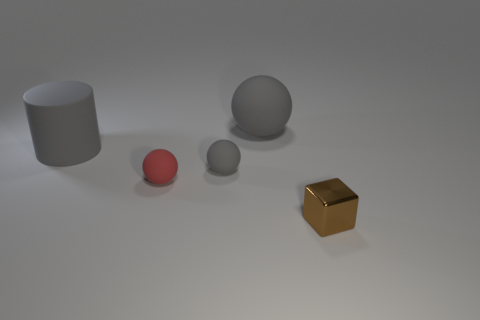Subtract all tiny rubber spheres. How many spheres are left? 1 Subtract all gray spheres. How many spheres are left? 1 Subtract all green cylinders. How many red spheres are left? 1 Subtract all tiny matte balls. Subtract all gray spheres. How many objects are left? 1 Add 5 red matte objects. How many red matte objects are left? 6 Add 3 small metallic things. How many small metallic things exist? 4 Add 1 red things. How many objects exist? 6 Subtract 1 brown cubes. How many objects are left? 4 Subtract all cylinders. How many objects are left? 4 Subtract 2 spheres. How many spheres are left? 1 